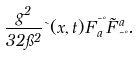<formula> <loc_0><loc_0><loc_500><loc_500>\frac { g ^ { 2 } } { 3 2 \pi ^ { 2 } } \theta ( x , t ) F ^ { \mu \nu } _ { a } \tilde { F } ^ { a } _ { \mu \nu } .</formula> 